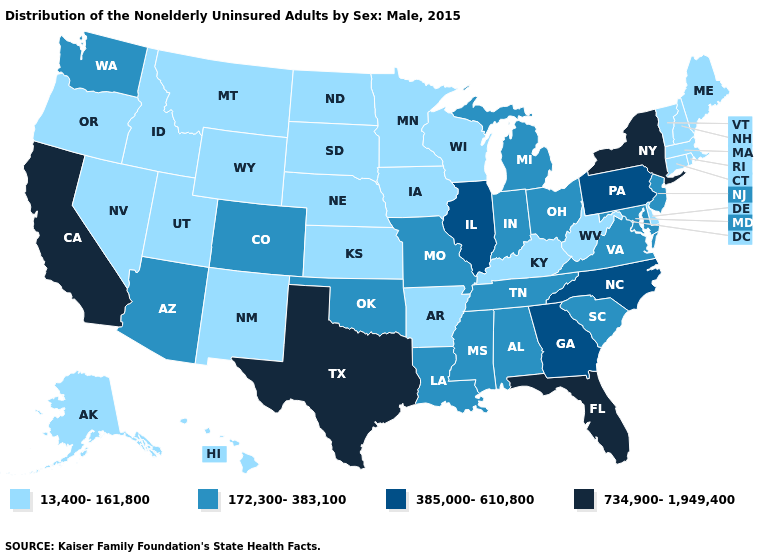Name the states that have a value in the range 734,900-1,949,400?
Answer briefly. California, Florida, New York, Texas. What is the value of Rhode Island?
Concise answer only. 13,400-161,800. Name the states that have a value in the range 734,900-1,949,400?
Write a very short answer. California, Florida, New York, Texas. What is the value of Washington?
Answer briefly. 172,300-383,100. Does Alabama have the same value as Nevada?
Be succinct. No. Which states hav the highest value in the West?
Short answer required. California. Does Louisiana have the lowest value in the USA?
Write a very short answer. No. Does the first symbol in the legend represent the smallest category?
Short answer required. Yes. Which states have the lowest value in the USA?
Give a very brief answer. Alaska, Arkansas, Connecticut, Delaware, Hawaii, Idaho, Iowa, Kansas, Kentucky, Maine, Massachusetts, Minnesota, Montana, Nebraska, Nevada, New Hampshire, New Mexico, North Dakota, Oregon, Rhode Island, South Dakota, Utah, Vermont, West Virginia, Wisconsin, Wyoming. What is the highest value in the USA?
Concise answer only. 734,900-1,949,400. What is the lowest value in states that border Pennsylvania?
Be succinct. 13,400-161,800. Among the states that border Indiana , which have the lowest value?
Write a very short answer. Kentucky. Name the states that have a value in the range 172,300-383,100?
Answer briefly. Alabama, Arizona, Colorado, Indiana, Louisiana, Maryland, Michigan, Mississippi, Missouri, New Jersey, Ohio, Oklahoma, South Carolina, Tennessee, Virginia, Washington. What is the highest value in the USA?
Write a very short answer. 734,900-1,949,400. What is the lowest value in the South?
Keep it brief. 13,400-161,800. 